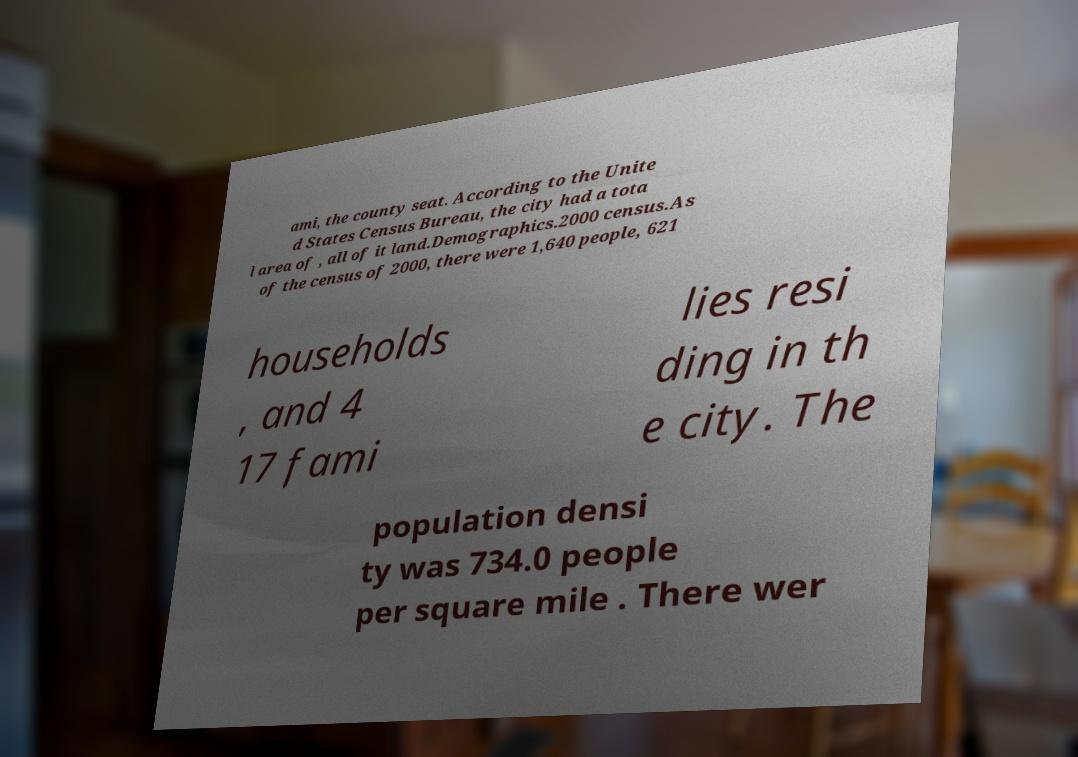For documentation purposes, I need the text within this image transcribed. Could you provide that? ami, the county seat. According to the Unite d States Census Bureau, the city had a tota l area of , all of it land.Demographics.2000 census.As of the census of 2000, there were 1,640 people, 621 households , and 4 17 fami lies resi ding in th e city. The population densi ty was 734.0 people per square mile . There wer 